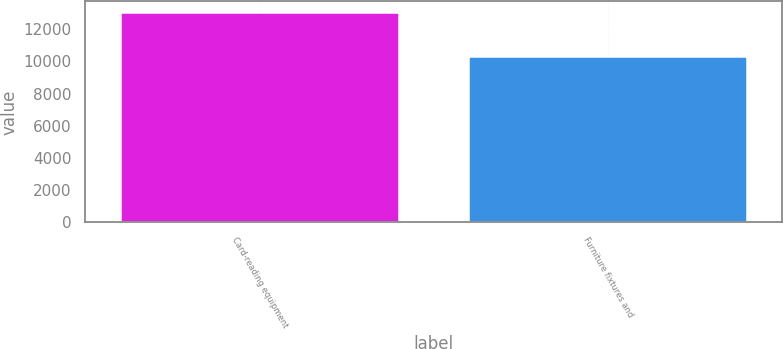Convert chart. <chart><loc_0><loc_0><loc_500><loc_500><bar_chart><fcel>Card-reading equipment<fcel>Furniture fixtures and<nl><fcel>13066<fcel>10319<nl></chart> 